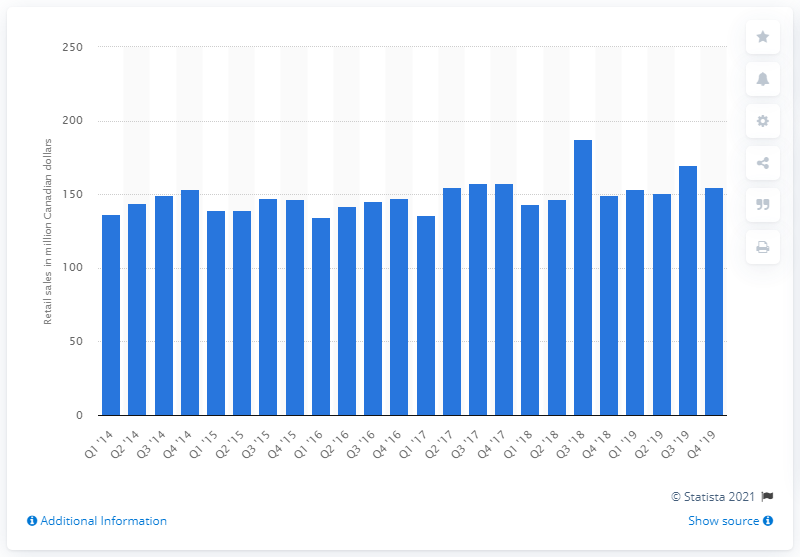Draw attention to some important aspects in this diagram. In the fourth quarter of 2019, the retail sales of disposable diapers in Canada totaled 154.6 million units. 